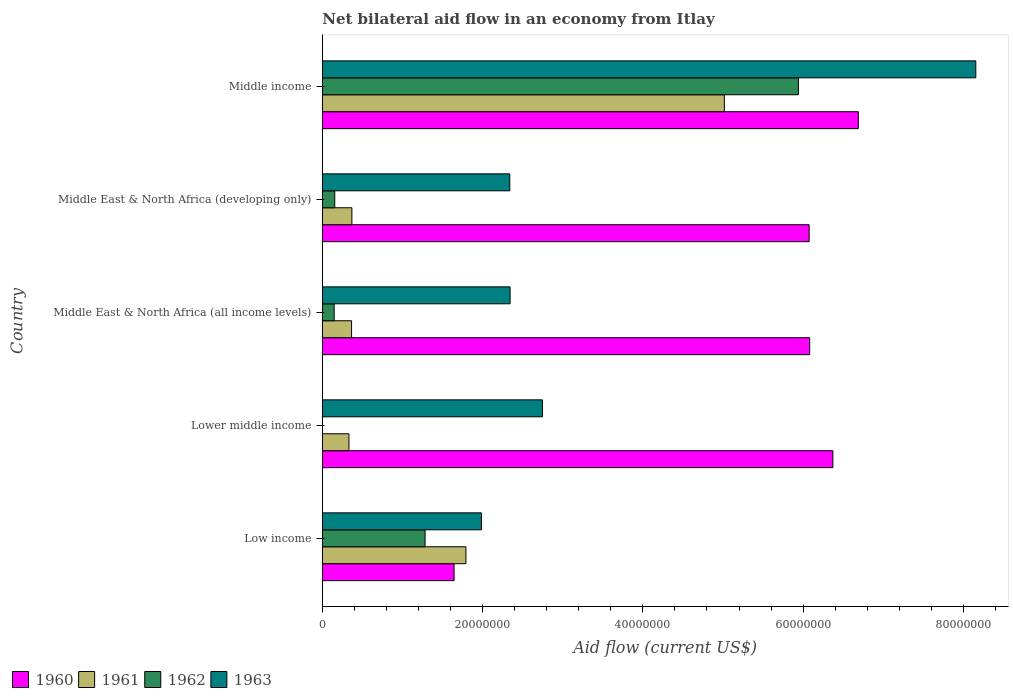How many different coloured bars are there?
Give a very brief answer. 4. How many groups of bars are there?
Keep it short and to the point. 5. Are the number of bars per tick equal to the number of legend labels?
Ensure brevity in your answer.  No. Are the number of bars on each tick of the Y-axis equal?
Provide a short and direct response. No. How many bars are there on the 4th tick from the bottom?
Your response must be concise. 4. What is the label of the 2nd group of bars from the top?
Your answer should be very brief. Middle East & North Africa (developing only). What is the net bilateral aid flow in 1963 in Middle income?
Offer a terse response. 8.16e+07. Across all countries, what is the maximum net bilateral aid flow in 1961?
Your answer should be very brief. 5.02e+07. Across all countries, what is the minimum net bilateral aid flow in 1963?
Keep it short and to the point. 1.99e+07. What is the total net bilateral aid flow in 1960 in the graph?
Ensure brevity in your answer.  2.69e+08. What is the difference between the net bilateral aid flow in 1961 in Lower middle income and that in Middle income?
Provide a short and direct response. -4.68e+07. What is the difference between the net bilateral aid flow in 1963 in Middle income and the net bilateral aid flow in 1962 in Middle East & North Africa (developing only)?
Keep it short and to the point. 8.00e+07. What is the average net bilateral aid flow in 1962 per country?
Provide a short and direct response. 1.51e+07. What is the difference between the net bilateral aid flow in 1962 and net bilateral aid flow in 1960 in Middle East & North Africa (developing only)?
Provide a succinct answer. -5.92e+07. What is the ratio of the net bilateral aid flow in 1963 in Lower middle income to that in Middle income?
Keep it short and to the point. 0.34. Is the net bilateral aid flow in 1963 in Middle East & North Africa (all income levels) less than that in Middle East & North Africa (developing only)?
Your response must be concise. No. What is the difference between the highest and the second highest net bilateral aid flow in 1961?
Give a very brief answer. 3.22e+07. What is the difference between the highest and the lowest net bilateral aid flow in 1961?
Offer a very short reply. 4.68e+07. How many bars are there?
Provide a succinct answer. 19. Are all the bars in the graph horizontal?
Provide a short and direct response. Yes. What is the difference between two consecutive major ticks on the X-axis?
Offer a terse response. 2.00e+07. Are the values on the major ticks of X-axis written in scientific E-notation?
Ensure brevity in your answer.  No. Where does the legend appear in the graph?
Give a very brief answer. Bottom left. How are the legend labels stacked?
Provide a short and direct response. Horizontal. What is the title of the graph?
Keep it short and to the point. Net bilateral aid flow in an economy from Itlay. What is the label or title of the X-axis?
Your answer should be compact. Aid flow (current US$). What is the label or title of the Y-axis?
Your response must be concise. Country. What is the Aid flow (current US$) in 1960 in Low income?
Provide a short and direct response. 1.64e+07. What is the Aid flow (current US$) in 1961 in Low income?
Give a very brief answer. 1.79e+07. What is the Aid flow (current US$) of 1962 in Low income?
Ensure brevity in your answer.  1.28e+07. What is the Aid flow (current US$) in 1963 in Low income?
Ensure brevity in your answer.  1.99e+07. What is the Aid flow (current US$) of 1960 in Lower middle income?
Make the answer very short. 6.37e+07. What is the Aid flow (current US$) of 1961 in Lower middle income?
Provide a succinct answer. 3.32e+06. What is the Aid flow (current US$) of 1962 in Lower middle income?
Make the answer very short. 0. What is the Aid flow (current US$) in 1963 in Lower middle income?
Your response must be concise. 2.75e+07. What is the Aid flow (current US$) in 1960 in Middle East & North Africa (all income levels)?
Offer a terse response. 6.08e+07. What is the Aid flow (current US$) in 1961 in Middle East & North Africa (all income levels)?
Offer a terse response. 3.65e+06. What is the Aid flow (current US$) in 1962 in Middle East & North Africa (all income levels)?
Your answer should be very brief. 1.48e+06. What is the Aid flow (current US$) of 1963 in Middle East & North Africa (all income levels)?
Provide a short and direct response. 2.34e+07. What is the Aid flow (current US$) in 1960 in Middle East & North Africa (developing only)?
Provide a short and direct response. 6.08e+07. What is the Aid flow (current US$) in 1961 in Middle East & North Africa (developing only)?
Your answer should be compact. 3.69e+06. What is the Aid flow (current US$) of 1962 in Middle East & North Africa (developing only)?
Make the answer very short. 1.55e+06. What is the Aid flow (current US$) of 1963 in Middle East & North Africa (developing only)?
Your response must be concise. 2.34e+07. What is the Aid flow (current US$) of 1960 in Middle income?
Offer a very short reply. 6.69e+07. What is the Aid flow (current US$) in 1961 in Middle income?
Give a very brief answer. 5.02e+07. What is the Aid flow (current US$) in 1962 in Middle income?
Your answer should be very brief. 5.94e+07. What is the Aid flow (current US$) of 1963 in Middle income?
Your answer should be compact. 8.16e+07. Across all countries, what is the maximum Aid flow (current US$) of 1960?
Offer a terse response. 6.69e+07. Across all countries, what is the maximum Aid flow (current US$) of 1961?
Your response must be concise. 5.02e+07. Across all countries, what is the maximum Aid flow (current US$) of 1962?
Offer a terse response. 5.94e+07. Across all countries, what is the maximum Aid flow (current US$) of 1963?
Offer a very short reply. 8.16e+07. Across all countries, what is the minimum Aid flow (current US$) in 1960?
Offer a terse response. 1.64e+07. Across all countries, what is the minimum Aid flow (current US$) in 1961?
Ensure brevity in your answer.  3.32e+06. Across all countries, what is the minimum Aid flow (current US$) of 1962?
Your answer should be compact. 0. Across all countries, what is the minimum Aid flow (current US$) of 1963?
Keep it short and to the point. 1.99e+07. What is the total Aid flow (current US$) of 1960 in the graph?
Keep it short and to the point. 2.69e+08. What is the total Aid flow (current US$) of 1961 in the graph?
Your answer should be very brief. 7.88e+07. What is the total Aid flow (current US$) in 1962 in the graph?
Give a very brief answer. 7.53e+07. What is the total Aid flow (current US$) in 1963 in the graph?
Make the answer very short. 1.76e+08. What is the difference between the Aid flow (current US$) of 1960 in Low income and that in Lower middle income?
Make the answer very short. -4.73e+07. What is the difference between the Aid flow (current US$) of 1961 in Low income and that in Lower middle income?
Provide a short and direct response. 1.46e+07. What is the difference between the Aid flow (current US$) of 1963 in Low income and that in Lower middle income?
Offer a very short reply. -7.61e+06. What is the difference between the Aid flow (current US$) of 1960 in Low income and that in Middle East & North Africa (all income levels)?
Give a very brief answer. -4.44e+07. What is the difference between the Aid flow (current US$) of 1961 in Low income and that in Middle East & North Africa (all income levels)?
Keep it short and to the point. 1.43e+07. What is the difference between the Aid flow (current US$) in 1962 in Low income and that in Middle East & North Africa (all income levels)?
Offer a very short reply. 1.13e+07. What is the difference between the Aid flow (current US$) in 1963 in Low income and that in Middle East & North Africa (all income levels)?
Make the answer very short. -3.57e+06. What is the difference between the Aid flow (current US$) in 1960 in Low income and that in Middle East & North Africa (developing only)?
Ensure brevity in your answer.  -4.43e+07. What is the difference between the Aid flow (current US$) in 1961 in Low income and that in Middle East & North Africa (developing only)?
Your answer should be very brief. 1.42e+07. What is the difference between the Aid flow (current US$) of 1962 in Low income and that in Middle East & North Africa (developing only)?
Ensure brevity in your answer.  1.13e+07. What is the difference between the Aid flow (current US$) of 1963 in Low income and that in Middle East & North Africa (developing only)?
Your answer should be compact. -3.53e+06. What is the difference between the Aid flow (current US$) of 1960 in Low income and that in Middle income?
Ensure brevity in your answer.  -5.04e+07. What is the difference between the Aid flow (current US$) of 1961 in Low income and that in Middle income?
Offer a terse response. -3.22e+07. What is the difference between the Aid flow (current US$) of 1962 in Low income and that in Middle income?
Offer a very short reply. -4.66e+07. What is the difference between the Aid flow (current US$) of 1963 in Low income and that in Middle income?
Offer a very short reply. -6.17e+07. What is the difference between the Aid flow (current US$) of 1960 in Lower middle income and that in Middle East & North Africa (all income levels)?
Offer a terse response. 2.89e+06. What is the difference between the Aid flow (current US$) in 1961 in Lower middle income and that in Middle East & North Africa (all income levels)?
Make the answer very short. -3.30e+05. What is the difference between the Aid flow (current US$) in 1963 in Lower middle income and that in Middle East & North Africa (all income levels)?
Keep it short and to the point. 4.04e+06. What is the difference between the Aid flow (current US$) of 1960 in Lower middle income and that in Middle East & North Africa (developing only)?
Ensure brevity in your answer.  2.96e+06. What is the difference between the Aid flow (current US$) in 1961 in Lower middle income and that in Middle East & North Africa (developing only)?
Offer a terse response. -3.70e+05. What is the difference between the Aid flow (current US$) in 1963 in Lower middle income and that in Middle East & North Africa (developing only)?
Provide a succinct answer. 4.08e+06. What is the difference between the Aid flow (current US$) in 1960 in Lower middle income and that in Middle income?
Give a very brief answer. -3.18e+06. What is the difference between the Aid flow (current US$) of 1961 in Lower middle income and that in Middle income?
Provide a short and direct response. -4.68e+07. What is the difference between the Aid flow (current US$) in 1963 in Lower middle income and that in Middle income?
Provide a short and direct response. -5.41e+07. What is the difference between the Aid flow (current US$) of 1960 in Middle East & North Africa (all income levels) and that in Middle East & North Africa (developing only)?
Give a very brief answer. 7.00e+04. What is the difference between the Aid flow (current US$) of 1961 in Middle East & North Africa (all income levels) and that in Middle East & North Africa (developing only)?
Give a very brief answer. -4.00e+04. What is the difference between the Aid flow (current US$) in 1960 in Middle East & North Africa (all income levels) and that in Middle income?
Provide a short and direct response. -6.07e+06. What is the difference between the Aid flow (current US$) of 1961 in Middle East & North Africa (all income levels) and that in Middle income?
Your answer should be compact. -4.65e+07. What is the difference between the Aid flow (current US$) of 1962 in Middle East & North Africa (all income levels) and that in Middle income?
Keep it short and to the point. -5.79e+07. What is the difference between the Aid flow (current US$) of 1963 in Middle East & North Africa (all income levels) and that in Middle income?
Offer a very short reply. -5.81e+07. What is the difference between the Aid flow (current US$) of 1960 in Middle East & North Africa (developing only) and that in Middle income?
Provide a short and direct response. -6.14e+06. What is the difference between the Aid flow (current US$) of 1961 in Middle East & North Africa (developing only) and that in Middle income?
Keep it short and to the point. -4.65e+07. What is the difference between the Aid flow (current US$) in 1962 in Middle East & North Africa (developing only) and that in Middle income?
Give a very brief answer. -5.79e+07. What is the difference between the Aid flow (current US$) of 1963 in Middle East & North Africa (developing only) and that in Middle income?
Your response must be concise. -5.82e+07. What is the difference between the Aid flow (current US$) in 1960 in Low income and the Aid flow (current US$) in 1961 in Lower middle income?
Keep it short and to the point. 1.31e+07. What is the difference between the Aid flow (current US$) in 1960 in Low income and the Aid flow (current US$) in 1963 in Lower middle income?
Give a very brief answer. -1.10e+07. What is the difference between the Aid flow (current US$) in 1961 in Low income and the Aid flow (current US$) in 1963 in Lower middle income?
Keep it short and to the point. -9.55e+06. What is the difference between the Aid flow (current US$) of 1962 in Low income and the Aid flow (current US$) of 1963 in Lower middle income?
Offer a very short reply. -1.46e+07. What is the difference between the Aid flow (current US$) of 1960 in Low income and the Aid flow (current US$) of 1961 in Middle East & North Africa (all income levels)?
Offer a terse response. 1.28e+07. What is the difference between the Aid flow (current US$) in 1960 in Low income and the Aid flow (current US$) in 1962 in Middle East & North Africa (all income levels)?
Give a very brief answer. 1.50e+07. What is the difference between the Aid flow (current US$) of 1960 in Low income and the Aid flow (current US$) of 1963 in Middle East & North Africa (all income levels)?
Offer a very short reply. -6.99e+06. What is the difference between the Aid flow (current US$) of 1961 in Low income and the Aid flow (current US$) of 1962 in Middle East & North Africa (all income levels)?
Provide a succinct answer. 1.64e+07. What is the difference between the Aid flow (current US$) of 1961 in Low income and the Aid flow (current US$) of 1963 in Middle East & North Africa (all income levels)?
Make the answer very short. -5.51e+06. What is the difference between the Aid flow (current US$) in 1962 in Low income and the Aid flow (current US$) in 1963 in Middle East & North Africa (all income levels)?
Give a very brief answer. -1.06e+07. What is the difference between the Aid flow (current US$) in 1960 in Low income and the Aid flow (current US$) in 1961 in Middle East & North Africa (developing only)?
Offer a terse response. 1.28e+07. What is the difference between the Aid flow (current US$) of 1960 in Low income and the Aid flow (current US$) of 1962 in Middle East & North Africa (developing only)?
Provide a short and direct response. 1.49e+07. What is the difference between the Aid flow (current US$) of 1960 in Low income and the Aid flow (current US$) of 1963 in Middle East & North Africa (developing only)?
Give a very brief answer. -6.95e+06. What is the difference between the Aid flow (current US$) of 1961 in Low income and the Aid flow (current US$) of 1962 in Middle East & North Africa (developing only)?
Make the answer very short. 1.64e+07. What is the difference between the Aid flow (current US$) in 1961 in Low income and the Aid flow (current US$) in 1963 in Middle East & North Africa (developing only)?
Provide a succinct answer. -5.47e+06. What is the difference between the Aid flow (current US$) of 1962 in Low income and the Aid flow (current US$) of 1963 in Middle East & North Africa (developing only)?
Your answer should be compact. -1.06e+07. What is the difference between the Aid flow (current US$) in 1960 in Low income and the Aid flow (current US$) in 1961 in Middle income?
Make the answer very short. -3.37e+07. What is the difference between the Aid flow (current US$) of 1960 in Low income and the Aid flow (current US$) of 1962 in Middle income?
Keep it short and to the point. -4.30e+07. What is the difference between the Aid flow (current US$) in 1960 in Low income and the Aid flow (current US$) in 1963 in Middle income?
Offer a very short reply. -6.51e+07. What is the difference between the Aid flow (current US$) of 1961 in Low income and the Aid flow (current US$) of 1962 in Middle income?
Your response must be concise. -4.15e+07. What is the difference between the Aid flow (current US$) in 1961 in Low income and the Aid flow (current US$) in 1963 in Middle income?
Keep it short and to the point. -6.36e+07. What is the difference between the Aid flow (current US$) in 1962 in Low income and the Aid flow (current US$) in 1963 in Middle income?
Ensure brevity in your answer.  -6.87e+07. What is the difference between the Aid flow (current US$) of 1960 in Lower middle income and the Aid flow (current US$) of 1961 in Middle East & North Africa (all income levels)?
Ensure brevity in your answer.  6.01e+07. What is the difference between the Aid flow (current US$) in 1960 in Lower middle income and the Aid flow (current US$) in 1962 in Middle East & North Africa (all income levels)?
Offer a very short reply. 6.22e+07. What is the difference between the Aid flow (current US$) of 1960 in Lower middle income and the Aid flow (current US$) of 1963 in Middle East & North Africa (all income levels)?
Your response must be concise. 4.03e+07. What is the difference between the Aid flow (current US$) of 1961 in Lower middle income and the Aid flow (current US$) of 1962 in Middle East & North Africa (all income levels)?
Provide a short and direct response. 1.84e+06. What is the difference between the Aid flow (current US$) in 1961 in Lower middle income and the Aid flow (current US$) in 1963 in Middle East & North Africa (all income levels)?
Your response must be concise. -2.01e+07. What is the difference between the Aid flow (current US$) of 1960 in Lower middle income and the Aid flow (current US$) of 1961 in Middle East & North Africa (developing only)?
Provide a succinct answer. 6.00e+07. What is the difference between the Aid flow (current US$) of 1960 in Lower middle income and the Aid flow (current US$) of 1962 in Middle East & North Africa (developing only)?
Your response must be concise. 6.22e+07. What is the difference between the Aid flow (current US$) in 1960 in Lower middle income and the Aid flow (current US$) in 1963 in Middle East & North Africa (developing only)?
Provide a short and direct response. 4.03e+07. What is the difference between the Aid flow (current US$) of 1961 in Lower middle income and the Aid flow (current US$) of 1962 in Middle East & North Africa (developing only)?
Provide a short and direct response. 1.77e+06. What is the difference between the Aid flow (current US$) of 1961 in Lower middle income and the Aid flow (current US$) of 1963 in Middle East & North Africa (developing only)?
Keep it short and to the point. -2.01e+07. What is the difference between the Aid flow (current US$) in 1960 in Lower middle income and the Aid flow (current US$) in 1961 in Middle income?
Offer a very short reply. 1.35e+07. What is the difference between the Aid flow (current US$) of 1960 in Lower middle income and the Aid flow (current US$) of 1962 in Middle income?
Offer a terse response. 4.30e+06. What is the difference between the Aid flow (current US$) of 1960 in Lower middle income and the Aid flow (current US$) of 1963 in Middle income?
Offer a very short reply. -1.78e+07. What is the difference between the Aid flow (current US$) in 1961 in Lower middle income and the Aid flow (current US$) in 1962 in Middle income?
Ensure brevity in your answer.  -5.61e+07. What is the difference between the Aid flow (current US$) of 1961 in Lower middle income and the Aid flow (current US$) of 1963 in Middle income?
Offer a very short reply. -7.82e+07. What is the difference between the Aid flow (current US$) of 1960 in Middle East & North Africa (all income levels) and the Aid flow (current US$) of 1961 in Middle East & North Africa (developing only)?
Your answer should be compact. 5.71e+07. What is the difference between the Aid flow (current US$) in 1960 in Middle East & North Africa (all income levels) and the Aid flow (current US$) in 1962 in Middle East & North Africa (developing only)?
Offer a very short reply. 5.93e+07. What is the difference between the Aid flow (current US$) of 1960 in Middle East & North Africa (all income levels) and the Aid flow (current US$) of 1963 in Middle East & North Africa (developing only)?
Provide a short and direct response. 3.74e+07. What is the difference between the Aid flow (current US$) of 1961 in Middle East & North Africa (all income levels) and the Aid flow (current US$) of 1962 in Middle East & North Africa (developing only)?
Your response must be concise. 2.10e+06. What is the difference between the Aid flow (current US$) in 1961 in Middle East & North Africa (all income levels) and the Aid flow (current US$) in 1963 in Middle East & North Africa (developing only)?
Offer a very short reply. -1.97e+07. What is the difference between the Aid flow (current US$) in 1962 in Middle East & North Africa (all income levels) and the Aid flow (current US$) in 1963 in Middle East & North Africa (developing only)?
Make the answer very short. -2.19e+07. What is the difference between the Aid flow (current US$) in 1960 in Middle East & North Africa (all income levels) and the Aid flow (current US$) in 1961 in Middle income?
Provide a succinct answer. 1.06e+07. What is the difference between the Aid flow (current US$) of 1960 in Middle East & North Africa (all income levels) and the Aid flow (current US$) of 1962 in Middle income?
Give a very brief answer. 1.41e+06. What is the difference between the Aid flow (current US$) in 1960 in Middle East & North Africa (all income levels) and the Aid flow (current US$) in 1963 in Middle income?
Provide a short and direct response. -2.07e+07. What is the difference between the Aid flow (current US$) of 1961 in Middle East & North Africa (all income levels) and the Aid flow (current US$) of 1962 in Middle income?
Your response must be concise. -5.58e+07. What is the difference between the Aid flow (current US$) in 1961 in Middle East & North Africa (all income levels) and the Aid flow (current US$) in 1963 in Middle income?
Your response must be concise. -7.79e+07. What is the difference between the Aid flow (current US$) of 1962 in Middle East & North Africa (all income levels) and the Aid flow (current US$) of 1963 in Middle income?
Keep it short and to the point. -8.01e+07. What is the difference between the Aid flow (current US$) in 1960 in Middle East & North Africa (developing only) and the Aid flow (current US$) in 1961 in Middle income?
Make the answer very short. 1.06e+07. What is the difference between the Aid flow (current US$) in 1960 in Middle East & North Africa (developing only) and the Aid flow (current US$) in 1962 in Middle income?
Your response must be concise. 1.34e+06. What is the difference between the Aid flow (current US$) of 1960 in Middle East & North Africa (developing only) and the Aid flow (current US$) of 1963 in Middle income?
Your answer should be very brief. -2.08e+07. What is the difference between the Aid flow (current US$) of 1961 in Middle East & North Africa (developing only) and the Aid flow (current US$) of 1962 in Middle income?
Offer a terse response. -5.57e+07. What is the difference between the Aid flow (current US$) of 1961 in Middle East & North Africa (developing only) and the Aid flow (current US$) of 1963 in Middle income?
Provide a short and direct response. -7.79e+07. What is the difference between the Aid flow (current US$) in 1962 in Middle East & North Africa (developing only) and the Aid flow (current US$) in 1963 in Middle income?
Offer a terse response. -8.00e+07. What is the average Aid flow (current US$) of 1960 per country?
Your response must be concise. 5.37e+07. What is the average Aid flow (current US$) in 1961 per country?
Keep it short and to the point. 1.58e+07. What is the average Aid flow (current US$) of 1962 per country?
Offer a very short reply. 1.51e+07. What is the average Aid flow (current US$) of 1963 per country?
Make the answer very short. 3.51e+07. What is the difference between the Aid flow (current US$) of 1960 and Aid flow (current US$) of 1961 in Low income?
Your answer should be very brief. -1.48e+06. What is the difference between the Aid flow (current US$) in 1960 and Aid flow (current US$) in 1962 in Low income?
Your response must be concise. 3.62e+06. What is the difference between the Aid flow (current US$) of 1960 and Aid flow (current US$) of 1963 in Low income?
Ensure brevity in your answer.  -3.42e+06. What is the difference between the Aid flow (current US$) in 1961 and Aid flow (current US$) in 1962 in Low income?
Ensure brevity in your answer.  5.10e+06. What is the difference between the Aid flow (current US$) of 1961 and Aid flow (current US$) of 1963 in Low income?
Offer a terse response. -1.94e+06. What is the difference between the Aid flow (current US$) of 1962 and Aid flow (current US$) of 1963 in Low income?
Your answer should be compact. -7.04e+06. What is the difference between the Aid flow (current US$) of 1960 and Aid flow (current US$) of 1961 in Lower middle income?
Provide a short and direct response. 6.04e+07. What is the difference between the Aid flow (current US$) of 1960 and Aid flow (current US$) of 1963 in Lower middle income?
Offer a very short reply. 3.62e+07. What is the difference between the Aid flow (current US$) in 1961 and Aid flow (current US$) in 1963 in Lower middle income?
Ensure brevity in your answer.  -2.42e+07. What is the difference between the Aid flow (current US$) in 1960 and Aid flow (current US$) in 1961 in Middle East & North Africa (all income levels)?
Offer a terse response. 5.72e+07. What is the difference between the Aid flow (current US$) in 1960 and Aid flow (current US$) in 1962 in Middle East & North Africa (all income levels)?
Ensure brevity in your answer.  5.93e+07. What is the difference between the Aid flow (current US$) in 1960 and Aid flow (current US$) in 1963 in Middle East & North Africa (all income levels)?
Give a very brief answer. 3.74e+07. What is the difference between the Aid flow (current US$) in 1961 and Aid flow (current US$) in 1962 in Middle East & North Africa (all income levels)?
Offer a very short reply. 2.17e+06. What is the difference between the Aid flow (current US$) in 1961 and Aid flow (current US$) in 1963 in Middle East & North Africa (all income levels)?
Offer a very short reply. -1.98e+07. What is the difference between the Aid flow (current US$) in 1962 and Aid flow (current US$) in 1963 in Middle East & North Africa (all income levels)?
Keep it short and to the point. -2.20e+07. What is the difference between the Aid flow (current US$) of 1960 and Aid flow (current US$) of 1961 in Middle East & North Africa (developing only)?
Give a very brief answer. 5.71e+07. What is the difference between the Aid flow (current US$) in 1960 and Aid flow (current US$) in 1962 in Middle East & North Africa (developing only)?
Ensure brevity in your answer.  5.92e+07. What is the difference between the Aid flow (current US$) in 1960 and Aid flow (current US$) in 1963 in Middle East & North Africa (developing only)?
Your answer should be compact. 3.74e+07. What is the difference between the Aid flow (current US$) in 1961 and Aid flow (current US$) in 1962 in Middle East & North Africa (developing only)?
Make the answer very short. 2.14e+06. What is the difference between the Aid flow (current US$) of 1961 and Aid flow (current US$) of 1963 in Middle East & North Africa (developing only)?
Give a very brief answer. -1.97e+07. What is the difference between the Aid flow (current US$) of 1962 and Aid flow (current US$) of 1963 in Middle East & North Africa (developing only)?
Offer a very short reply. -2.18e+07. What is the difference between the Aid flow (current US$) in 1960 and Aid flow (current US$) in 1961 in Middle income?
Your answer should be compact. 1.67e+07. What is the difference between the Aid flow (current US$) in 1960 and Aid flow (current US$) in 1962 in Middle income?
Provide a succinct answer. 7.48e+06. What is the difference between the Aid flow (current US$) in 1960 and Aid flow (current US$) in 1963 in Middle income?
Offer a very short reply. -1.47e+07. What is the difference between the Aid flow (current US$) in 1961 and Aid flow (current US$) in 1962 in Middle income?
Make the answer very short. -9.24e+06. What is the difference between the Aid flow (current US$) of 1961 and Aid flow (current US$) of 1963 in Middle income?
Offer a very short reply. -3.14e+07. What is the difference between the Aid flow (current US$) of 1962 and Aid flow (current US$) of 1963 in Middle income?
Provide a succinct answer. -2.21e+07. What is the ratio of the Aid flow (current US$) in 1960 in Low income to that in Lower middle income?
Your response must be concise. 0.26. What is the ratio of the Aid flow (current US$) in 1961 in Low income to that in Lower middle income?
Your response must be concise. 5.4. What is the ratio of the Aid flow (current US$) of 1963 in Low income to that in Lower middle income?
Provide a succinct answer. 0.72. What is the ratio of the Aid flow (current US$) of 1960 in Low income to that in Middle East & North Africa (all income levels)?
Provide a short and direct response. 0.27. What is the ratio of the Aid flow (current US$) of 1961 in Low income to that in Middle East & North Africa (all income levels)?
Ensure brevity in your answer.  4.91. What is the ratio of the Aid flow (current US$) in 1962 in Low income to that in Middle East & North Africa (all income levels)?
Your answer should be very brief. 8.66. What is the ratio of the Aid flow (current US$) in 1963 in Low income to that in Middle East & North Africa (all income levels)?
Offer a terse response. 0.85. What is the ratio of the Aid flow (current US$) in 1960 in Low income to that in Middle East & North Africa (developing only)?
Offer a very short reply. 0.27. What is the ratio of the Aid flow (current US$) in 1961 in Low income to that in Middle East & North Africa (developing only)?
Make the answer very short. 4.86. What is the ratio of the Aid flow (current US$) in 1962 in Low income to that in Middle East & North Africa (developing only)?
Give a very brief answer. 8.27. What is the ratio of the Aid flow (current US$) in 1963 in Low income to that in Middle East & North Africa (developing only)?
Your answer should be very brief. 0.85. What is the ratio of the Aid flow (current US$) of 1960 in Low income to that in Middle income?
Give a very brief answer. 0.25. What is the ratio of the Aid flow (current US$) of 1961 in Low income to that in Middle income?
Your answer should be very brief. 0.36. What is the ratio of the Aid flow (current US$) of 1962 in Low income to that in Middle income?
Provide a succinct answer. 0.22. What is the ratio of the Aid flow (current US$) in 1963 in Low income to that in Middle income?
Your answer should be very brief. 0.24. What is the ratio of the Aid flow (current US$) in 1960 in Lower middle income to that in Middle East & North Africa (all income levels)?
Your answer should be very brief. 1.05. What is the ratio of the Aid flow (current US$) in 1961 in Lower middle income to that in Middle East & North Africa (all income levels)?
Provide a succinct answer. 0.91. What is the ratio of the Aid flow (current US$) of 1963 in Lower middle income to that in Middle East & North Africa (all income levels)?
Your answer should be compact. 1.17. What is the ratio of the Aid flow (current US$) of 1960 in Lower middle income to that in Middle East & North Africa (developing only)?
Provide a short and direct response. 1.05. What is the ratio of the Aid flow (current US$) of 1961 in Lower middle income to that in Middle East & North Africa (developing only)?
Ensure brevity in your answer.  0.9. What is the ratio of the Aid flow (current US$) in 1963 in Lower middle income to that in Middle East & North Africa (developing only)?
Offer a terse response. 1.17. What is the ratio of the Aid flow (current US$) of 1960 in Lower middle income to that in Middle income?
Keep it short and to the point. 0.95. What is the ratio of the Aid flow (current US$) in 1961 in Lower middle income to that in Middle income?
Ensure brevity in your answer.  0.07. What is the ratio of the Aid flow (current US$) of 1963 in Lower middle income to that in Middle income?
Your answer should be very brief. 0.34. What is the ratio of the Aid flow (current US$) of 1962 in Middle East & North Africa (all income levels) to that in Middle East & North Africa (developing only)?
Your response must be concise. 0.95. What is the ratio of the Aid flow (current US$) of 1960 in Middle East & North Africa (all income levels) to that in Middle income?
Provide a succinct answer. 0.91. What is the ratio of the Aid flow (current US$) in 1961 in Middle East & North Africa (all income levels) to that in Middle income?
Provide a short and direct response. 0.07. What is the ratio of the Aid flow (current US$) in 1962 in Middle East & North Africa (all income levels) to that in Middle income?
Keep it short and to the point. 0.02. What is the ratio of the Aid flow (current US$) of 1963 in Middle East & North Africa (all income levels) to that in Middle income?
Your answer should be very brief. 0.29. What is the ratio of the Aid flow (current US$) in 1960 in Middle East & North Africa (developing only) to that in Middle income?
Your response must be concise. 0.91. What is the ratio of the Aid flow (current US$) in 1961 in Middle East & North Africa (developing only) to that in Middle income?
Offer a terse response. 0.07. What is the ratio of the Aid flow (current US$) of 1962 in Middle East & North Africa (developing only) to that in Middle income?
Offer a very short reply. 0.03. What is the ratio of the Aid flow (current US$) of 1963 in Middle East & North Africa (developing only) to that in Middle income?
Give a very brief answer. 0.29. What is the difference between the highest and the second highest Aid flow (current US$) of 1960?
Keep it short and to the point. 3.18e+06. What is the difference between the highest and the second highest Aid flow (current US$) in 1961?
Your response must be concise. 3.22e+07. What is the difference between the highest and the second highest Aid flow (current US$) of 1962?
Keep it short and to the point. 4.66e+07. What is the difference between the highest and the second highest Aid flow (current US$) of 1963?
Offer a terse response. 5.41e+07. What is the difference between the highest and the lowest Aid flow (current US$) of 1960?
Ensure brevity in your answer.  5.04e+07. What is the difference between the highest and the lowest Aid flow (current US$) of 1961?
Provide a short and direct response. 4.68e+07. What is the difference between the highest and the lowest Aid flow (current US$) of 1962?
Your response must be concise. 5.94e+07. What is the difference between the highest and the lowest Aid flow (current US$) of 1963?
Your answer should be very brief. 6.17e+07. 